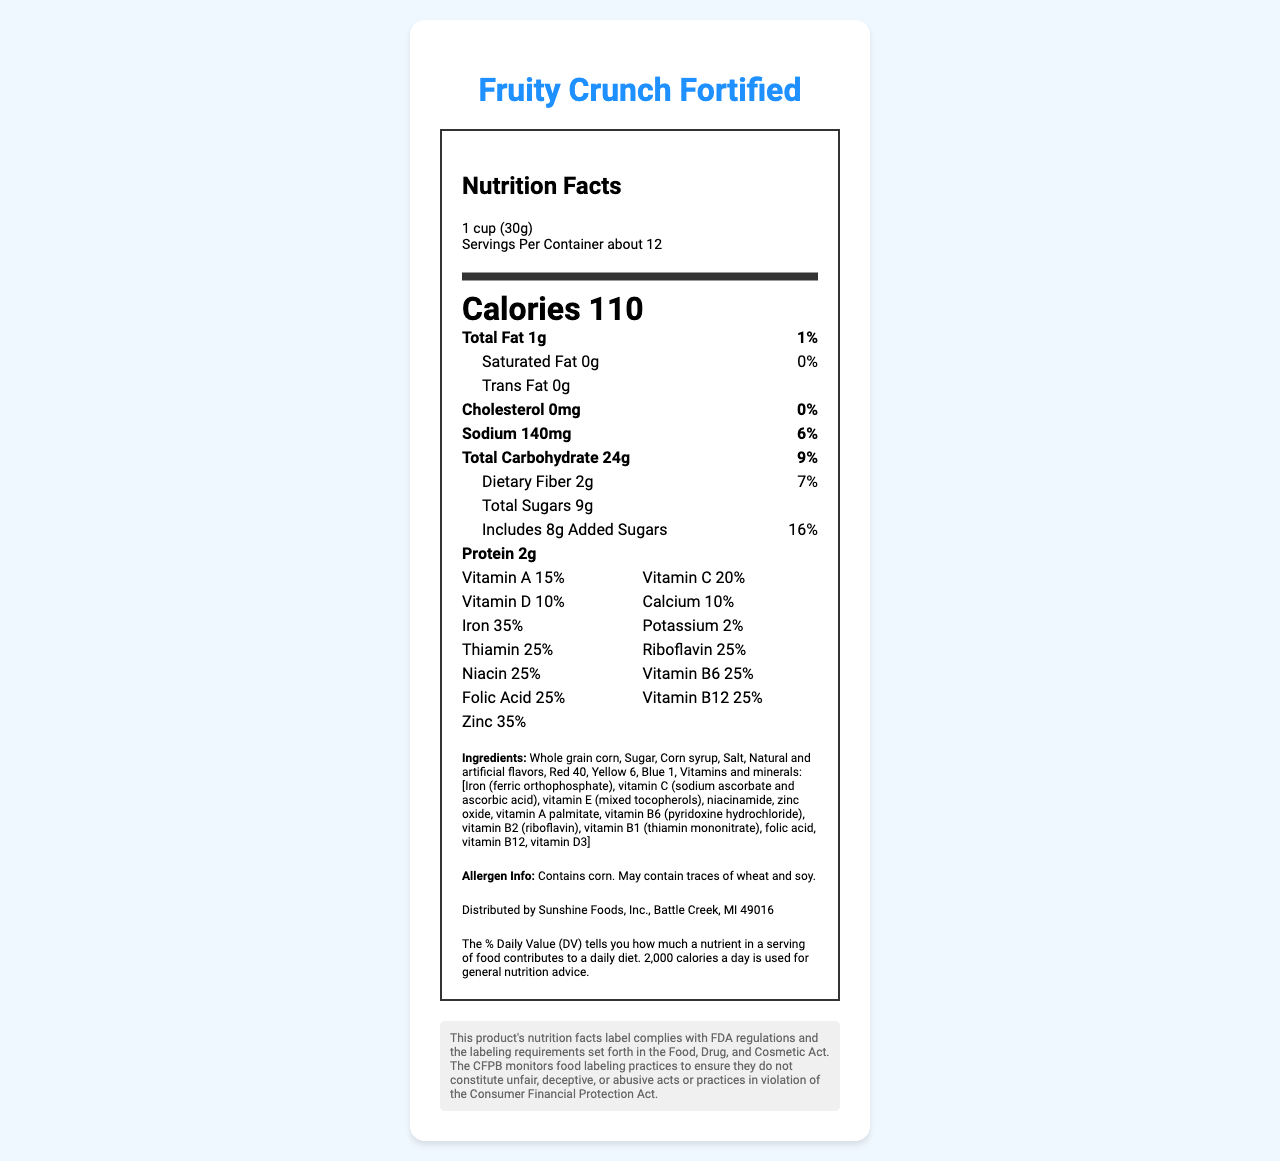what is the serving size? The document specifies the serving size as "1 cup (30g)" in the serving information.
Answer: 1 cup (30g) how many calories are in one serving? The document states that there are 110 calories per serving.
Answer: 110 what is the daily value percentage of sodium in one serving? The document indicates that one serving contains 140mg of sodium, which contributes to 6% of the daily value.
Answer: 6% which vitamins are present in 25% of the daily value? Vitamins present in 25% of the daily value are Thiamin (0.3mg), Riboflavin (0.34mg), Niacin (4mg), Vitamin B6 (0.4mg), Folic Acid (100mcg), and Vitamin B12 (0.6mcg).
Answer: Thiamin, Riboflavin, Niacin, Vitamin B6, Folic Acid, Vitamin B12 what is the allergen information provided? The document mentions that the cereal contains corn and may contain traces of wheat and soy.
Answer: Contains corn. May contain traces of wheat and soy. does the cereal contain any trans fat? The document specifically states that the cereal contains 0g of trans fat.
Answer: No who is the manufacturer of this cereal? The document lists Sunshine Foods, Inc. as the manufacturer.
Answer: Sunshine Foods, Inc. how many servings per container are there? The document states that there are about 12 servings per container.
Answer: about 12 which of the following vitamins is not listed in the nutrition facts? A. Vitamin A B. Vitamin K C. Vitamin D D. Vitamin C The nutrition facts list Vitamin A, Vitamin C, and Vitamin D, but Vitamin K is not mentioned.
Answer: B. Vitamin K how much iron is in one serving, and what percentage of the daily value does it represent? The document indicates that there is 6mg of iron in one serving, which corresponds to 35% of the daily value.
Answer: 6mg, 35% how many grams of total fat are in one serving? A. 0g B. 0.5g C. 1g D. 2g The document states that there is 1g of total fat in one serving.
Answer: C. 1g does the document state the source of the added sugars? The document mentions the amount of added sugars (8g), but it does not specify the source of these sugars.
Answer: Cannot be determined does the product comply with FDA regulations according to the document? The document includes a CFPB compliance note stating that the product's nutrition facts label complies with FDA regulations and labeling requirements.
Answer: Yes summarize the main idea of the document. The document aims to inform consumers about the nutritional content and ingredients of "Fruity Crunch Fortified" cereal, ensuring they are aware of what they are consuming and the regulatory compliance of the product. The label mentions serving sizes, calorie count, fat content, vitamin and mineral information, ingredients, allergen warnings, manufacturer details, and an FDA compliance note.
Answer: The document provides detailed nutritional information for "Fruity Crunch Fortified" cereal, including serving size, calorie content, vitamin and mineral percentages, ingredients, allergen info, and compliance with FDA regulations. 